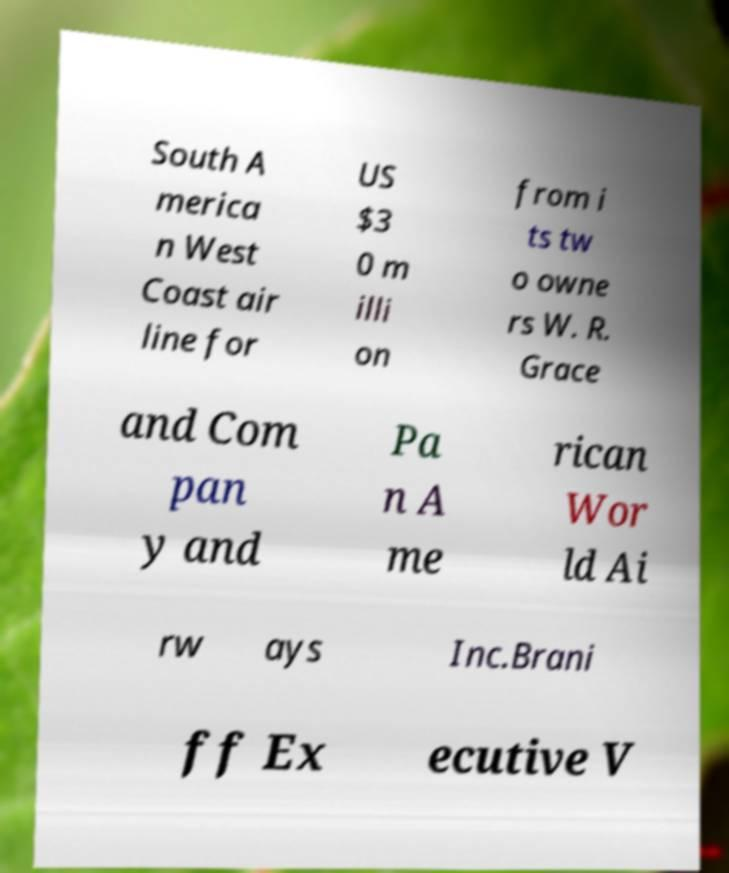Please read and relay the text visible in this image. What does it say? South A merica n West Coast air line for US $3 0 m illi on from i ts tw o owne rs W. R. Grace and Com pan y and Pa n A me rican Wor ld Ai rw ays Inc.Brani ff Ex ecutive V 